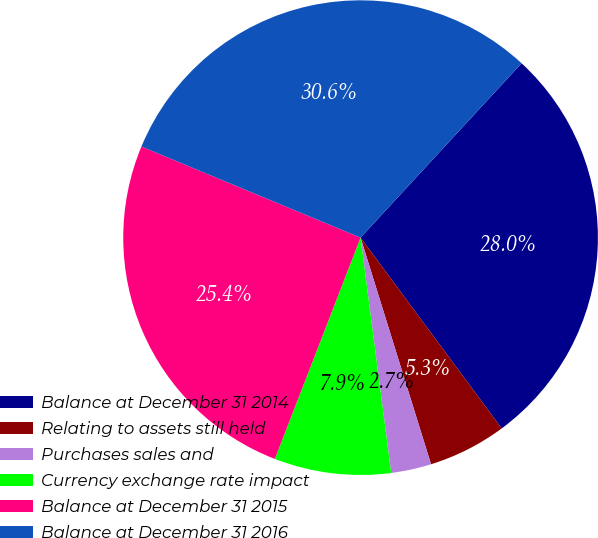<chart> <loc_0><loc_0><loc_500><loc_500><pie_chart><fcel>Balance at December 31 2014<fcel>Relating to assets still held<fcel>Purchases sales and<fcel>Currency exchange rate impact<fcel>Balance at December 31 2015<fcel>Balance at December 31 2016<nl><fcel>28.0%<fcel>5.34%<fcel>2.74%<fcel>7.94%<fcel>25.39%<fcel>30.6%<nl></chart> 